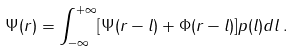<formula> <loc_0><loc_0><loc_500><loc_500>\Psi ( r ) = \int _ { - \infty } ^ { + \infty } [ \Psi ( r - l ) + \Phi ( r - l ) ] p ( l ) d l \, .</formula> 